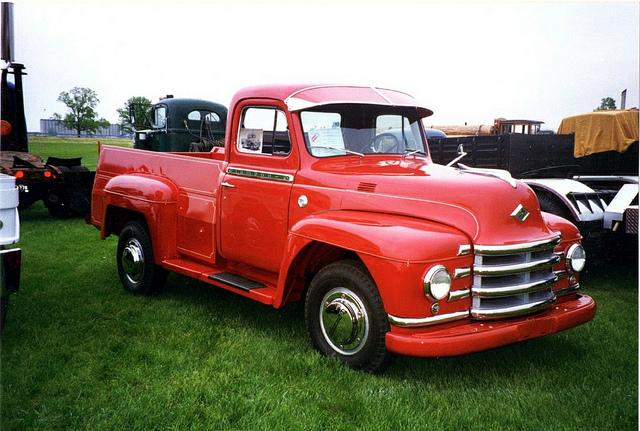What is this red truck for? owner preference 